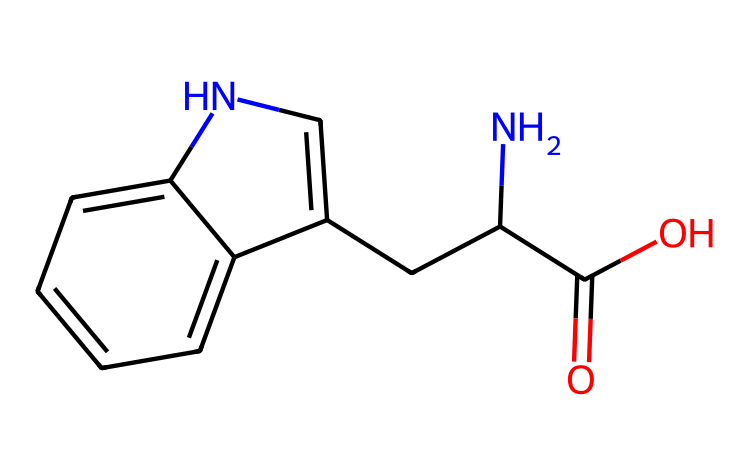What is the name of this chemical? The structure corresponds to the amino acid tryptophan, which can be identified by its specific arrangement of atoms and the presence of a nitrogen atom in the indole ring.
Answer: tryptophan How many carbon atoms are present in tryptophan? By examining the SMILES representation, we can count the carbon atoms indicated by the letter "C". There are 11 carbon atoms in total.
Answer: 11 What functional group is represented by the "C(=O)O" part in the structure? This portion represents a carboxylic acid functional group (the carbon atom is double bonded to an oxygen and single bonded to a hydroxyl group, "-OH").
Answer: carboxylic acid Does tryptophan contain any nitrogen atoms? Yes, the structure includes two nitrogen atoms, both of which are present in the indole ring and the amino group.
Answer: yes What type of ring structure is present in tryptophan? The presence of a fused ring structure containing nitrogen identifies it as an indole structure, which is characteristic of tryptophan.
Answer: indole How many hydrogen atoms are associated with the tryptophan molecule? Considering the typical valency of carbon and analyzing the structure, there are 12 hydrogen atoms in the overall structure.
Answer: 12 Is tryptophan classified as an aromatic compound? Yes, tryptophan is classified as an aromatic compound due to its indole ring, which has alternating double bonds and fulfills the criteria for aromaticity.
Answer: yes 